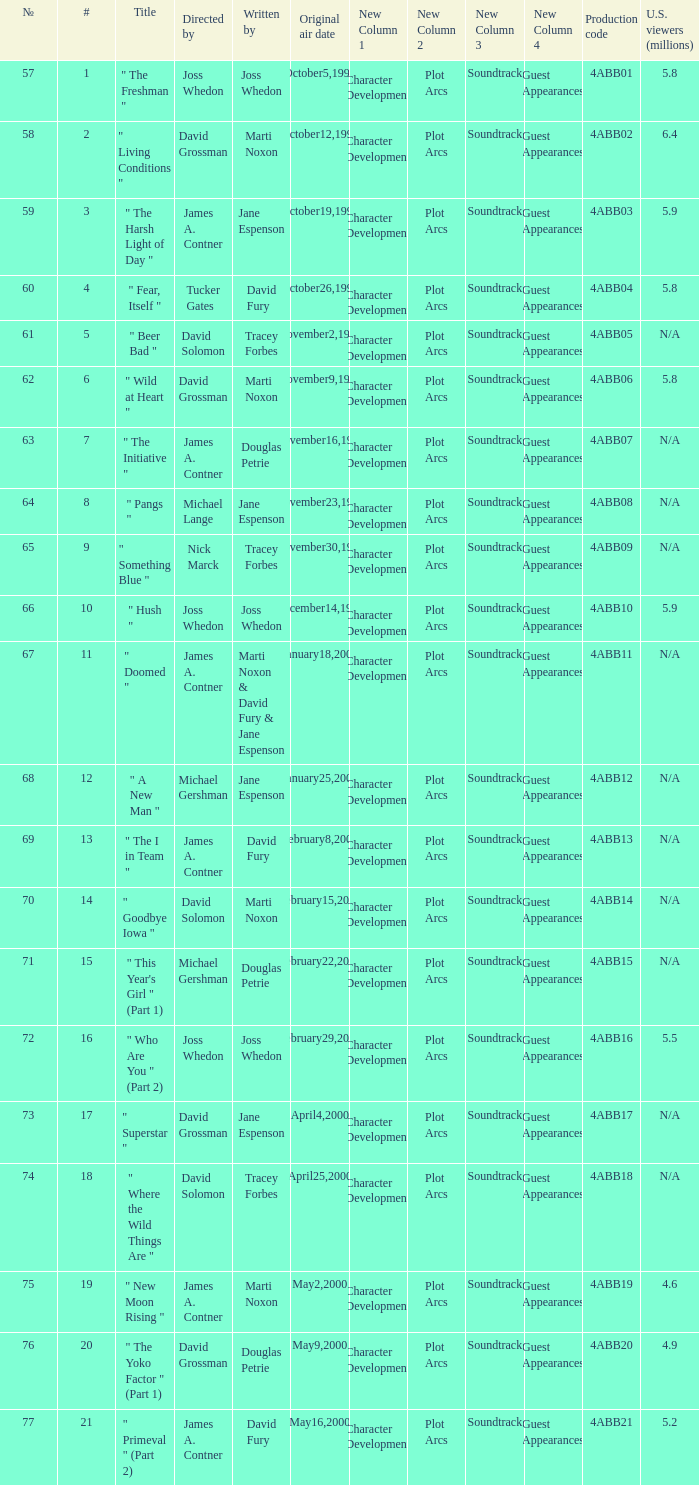What is the production code for the episode with 5.5 million u.s. viewers? 4ABB16. 